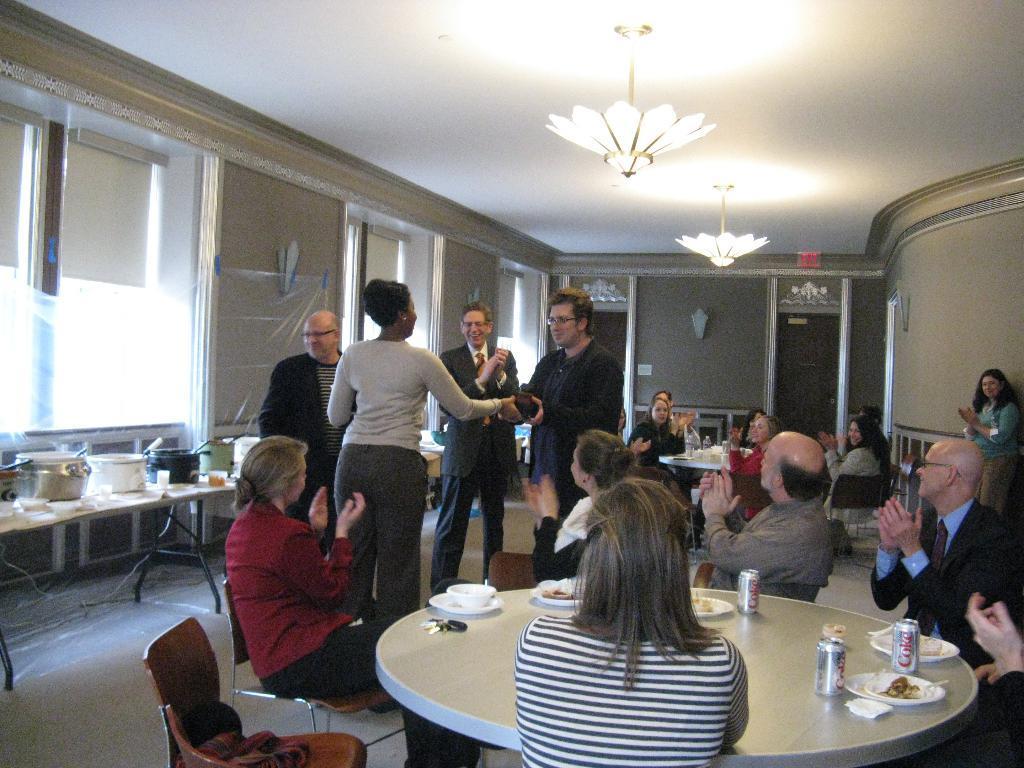Could you give a brief overview of what you see in this image? As we can see in the image there are lights, wall, table. On table there are bowls and few people sitting and standing. 